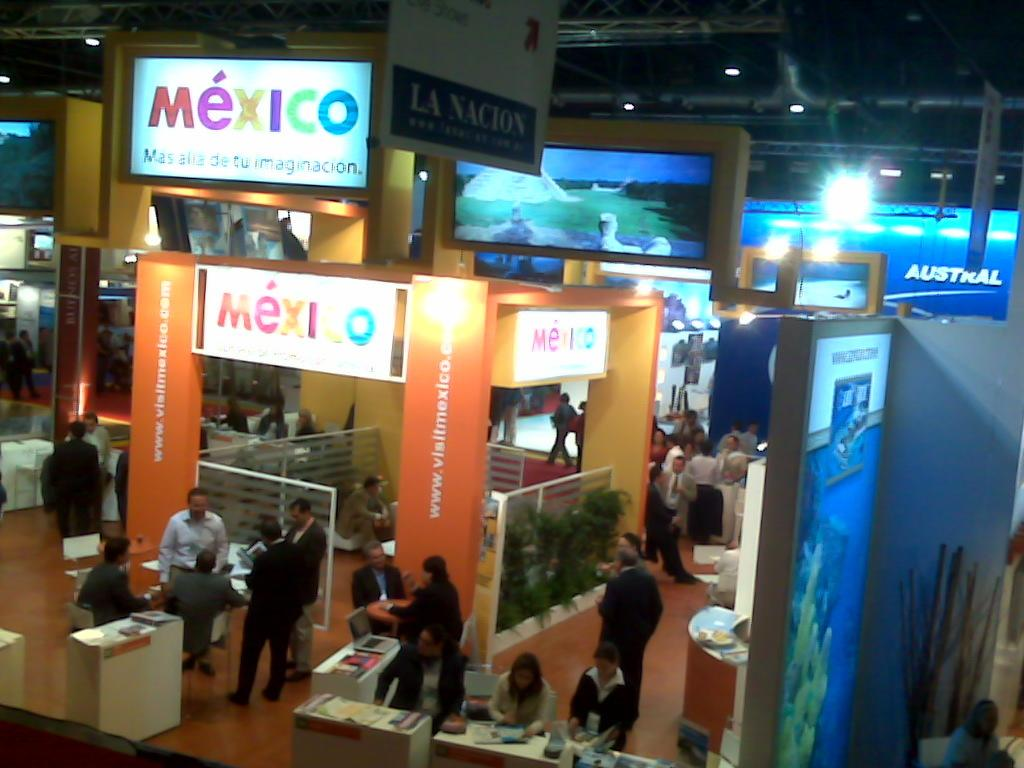<image>
Share a concise interpretation of the image provided. Several signs that say Mexico and people gathered around. 